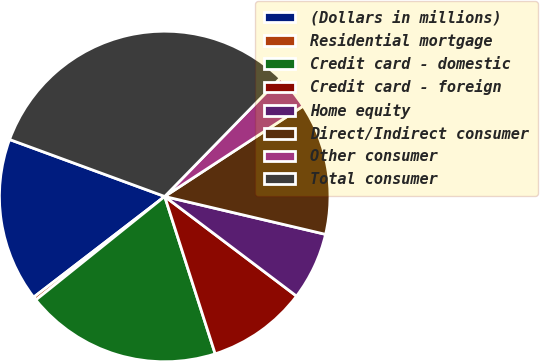Convert chart to OTSL. <chart><loc_0><loc_0><loc_500><loc_500><pie_chart><fcel>(Dollars in millions)<fcel>Residential mortgage<fcel>Credit card - domestic<fcel>Credit card - foreign<fcel>Home equity<fcel>Direct/Indirect consumer<fcel>Other consumer<fcel>Total consumer<nl><fcel>16.03%<fcel>0.34%<fcel>19.17%<fcel>9.76%<fcel>6.62%<fcel>12.89%<fcel>3.48%<fcel>31.71%<nl></chart> 